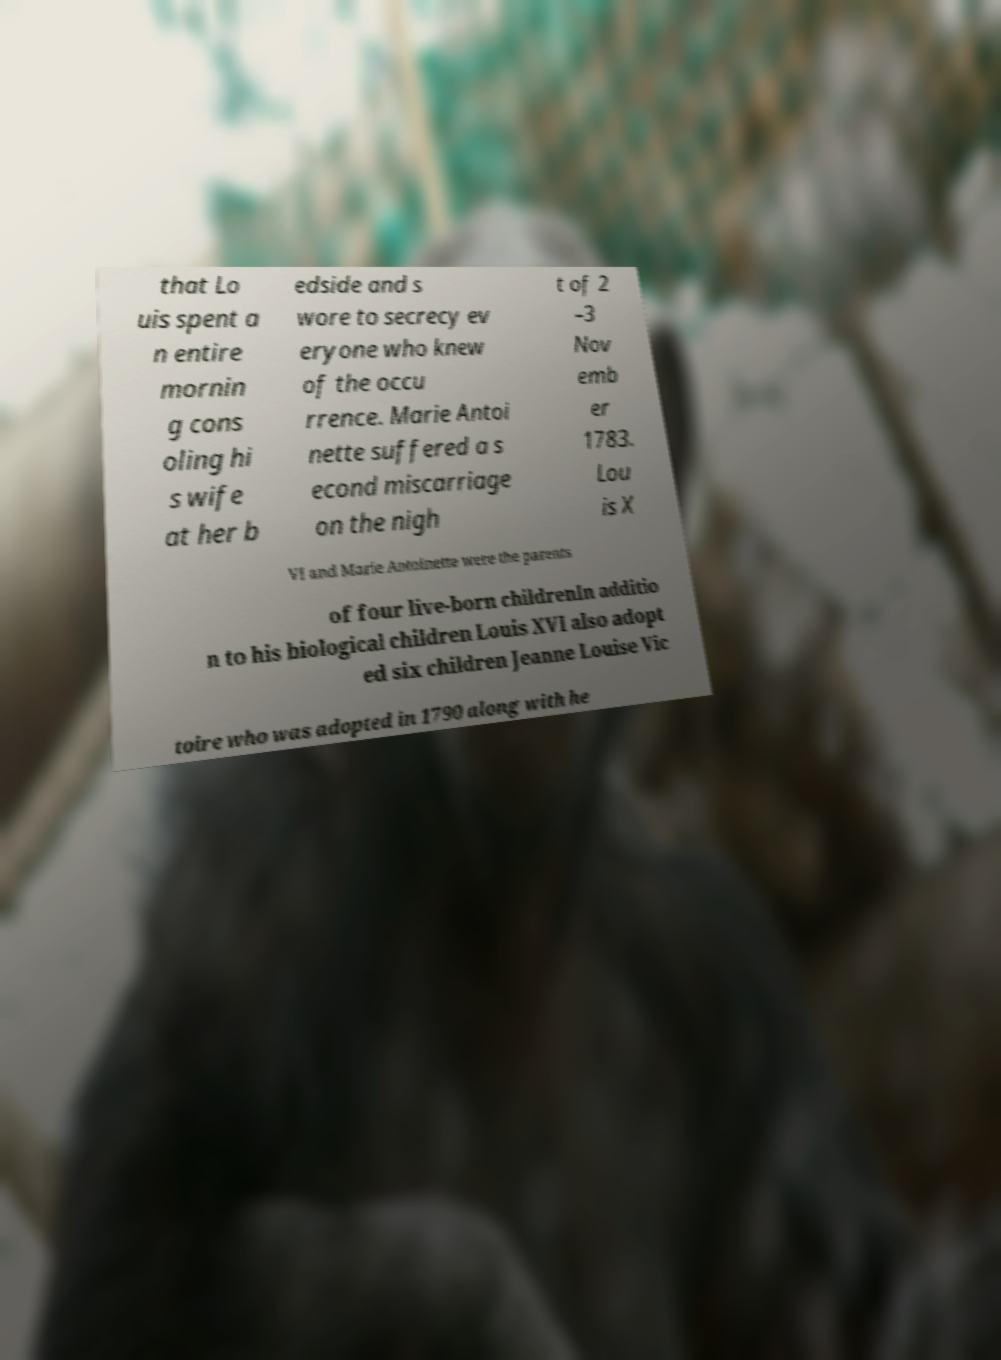Can you read and provide the text displayed in the image?This photo seems to have some interesting text. Can you extract and type it out for me? that Lo uis spent a n entire mornin g cons oling hi s wife at her b edside and s wore to secrecy ev eryone who knew of the occu rrence. Marie Antoi nette suffered a s econd miscarriage on the nigh t of 2 –3 Nov emb er 1783. Lou is X VI and Marie Antoinette were the parents of four live-born childrenIn additio n to his biological children Louis XVI also adopt ed six children Jeanne Louise Vic toire who was adopted in 1790 along with he 